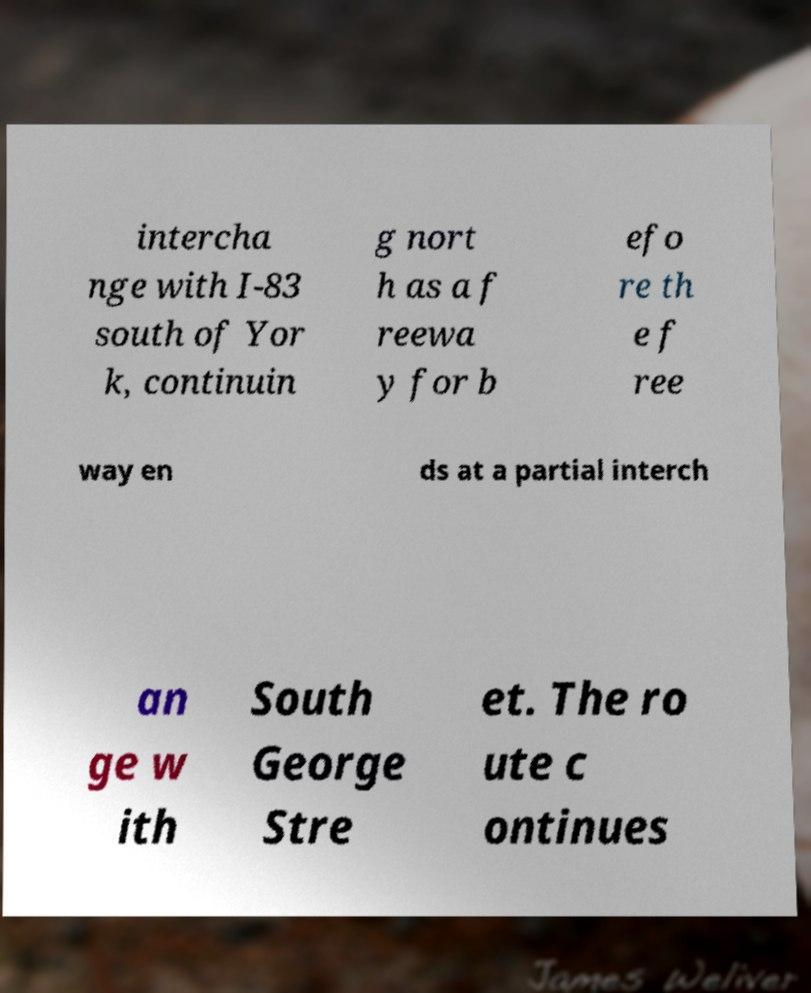I need the written content from this picture converted into text. Can you do that? intercha nge with I-83 south of Yor k, continuin g nort h as a f reewa y for b efo re th e f ree way en ds at a partial interch an ge w ith South George Stre et. The ro ute c ontinues 